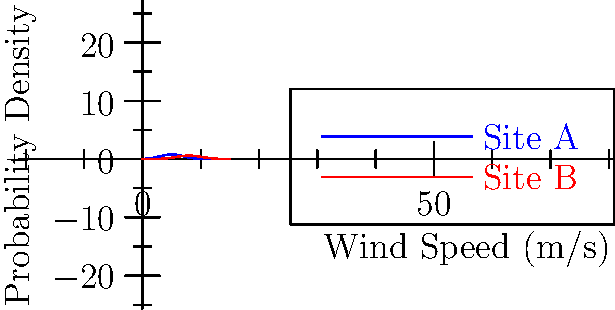As a sustainability advocate, you're advising on the optimal placement of wind turbines. The graph shows wind speed probability density functions for two potential sites. Which site would you recommend for wind turbine placement to maximize energy output, and why? To determine the optimal site for wind turbine placement, we need to consider the wind speed distribution and its impact on energy output. Let's analyze both sites:

1. Observe the graphs:
   - Site A (blue): Peak around 5 m/s, narrower distribution
   - Site B (red): Peak around 8 m/s, wider distribution

2. Consider wind turbine power generation:
   - Power output is proportional to the cube of wind speed ($$P \propto v^3$$)
   - Higher wind speeds generate significantly more power

3. Analyze Site A:
   - Peak at lower wind speed (5 m/s)
   - Narrower distribution means more consistent but lower wind speeds

4. Analyze Site B:
   - Peak at higher wind speed (8 m/s)
   - Wider distribution indicates more variability but higher potential for strong winds

5. Energy output comparison:
   - Site B's higher wind speeds will produce more energy due to the cubic relationship
   - The wider distribution of Site B includes more high-wind-speed events

6. Sustainability consideration:
   - Higher energy output from Site B means more efficient use of resources and land

Therefore, Site B is the recommended location for wind turbine placement as it offers higher potential for energy generation, making it more sustainable and efficient in the long run.
Answer: Site B, due to higher average wind speeds and greater energy potential. 